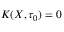<formula> <loc_0><loc_0><loc_500><loc_500>K ( X , \tau _ { 0 } ) = 0</formula> 